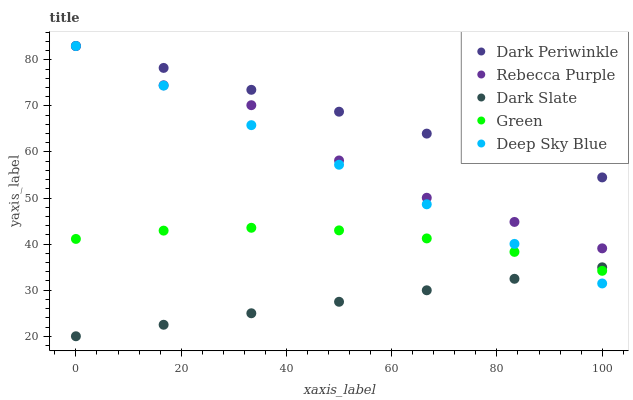Does Dark Slate have the minimum area under the curve?
Answer yes or no. Yes. Does Dark Periwinkle have the maximum area under the curve?
Answer yes or no. Yes. Does Green have the minimum area under the curve?
Answer yes or no. No. Does Green have the maximum area under the curve?
Answer yes or no. No. Is Dark Slate the smoothest?
Answer yes or no. Yes. Is Rebecca Purple the roughest?
Answer yes or no. Yes. Is Green the smoothest?
Answer yes or no. No. Is Green the roughest?
Answer yes or no. No. Does Dark Slate have the lowest value?
Answer yes or no. Yes. Does Green have the lowest value?
Answer yes or no. No. Does Rebecca Purple have the highest value?
Answer yes or no. Yes. Does Green have the highest value?
Answer yes or no. No. Is Green less than Rebecca Purple?
Answer yes or no. Yes. Is Dark Periwinkle greater than Dark Slate?
Answer yes or no. Yes. Does Dark Periwinkle intersect Deep Sky Blue?
Answer yes or no. Yes. Is Dark Periwinkle less than Deep Sky Blue?
Answer yes or no. No. Is Dark Periwinkle greater than Deep Sky Blue?
Answer yes or no. No. Does Green intersect Rebecca Purple?
Answer yes or no. No. 